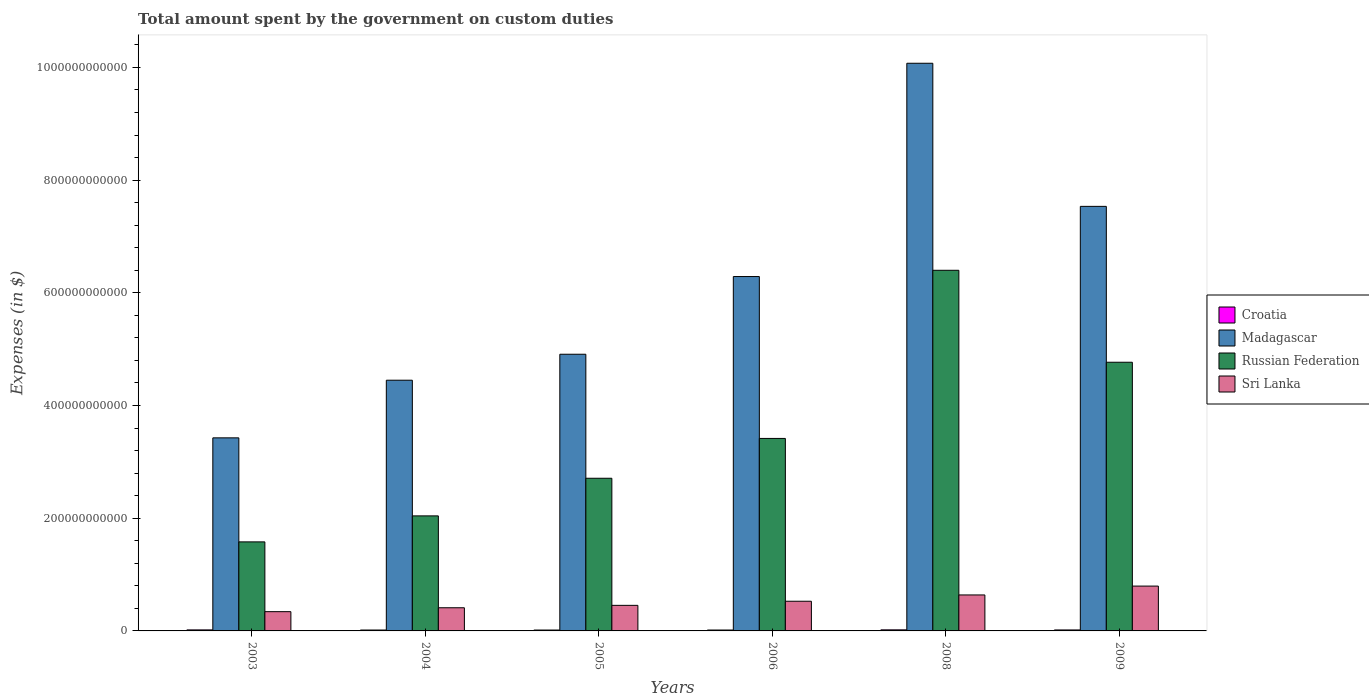How many groups of bars are there?
Ensure brevity in your answer.  6. Are the number of bars per tick equal to the number of legend labels?
Provide a succinct answer. Yes. In how many cases, is the number of bars for a given year not equal to the number of legend labels?
Your answer should be very brief. 0. What is the amount spent on custom duties by the government in Russian Federation in 2004?
Provide a succinct answer. 2.04e+11. Across all years, what is the maximum amount spent on custom duties by the government in Russian Federation?
Your response must be concise. 6.40e+11. Across all years, what is the minimum amount spent on custom duties by the government in Sri Lanka?
Make the answer very short. 3.42e+1. In which year was the amount spent on custom duties by the government in Russian Federation maximum?
Make the answer very short. 2008. In which year was the amount spent on custom duties by the government in Sri Lanka minimum?
Ensure brevity in your answer.  2003. What is the total amount spent on custom duties by the government in Croatia in the graph?
Your answer should be very brief. 1.02e+1. What is the difference between the amount spent on custom duties by the government in Sri Lanka in 2004 and that in 2006?
Your response must be concise. -1.16e+1. What is the difference between the amount spent on custom duties by the government in Sri Lanka in 2003 and the amount spent on custom duties by the government in Madagascar in 2005?
Ensure brevity in your answer.  -4.57e+11. What is the average amount spent on custom duties by the government in Croatia per year?
Provide a succinct answer. 1.70e+09. In the year 2008, what is the difference between the amount spent on custom duties by the government in Croatia and amount spent on custom duties by the government in Russian Federation?
Offer a very short reply. -6.38e+11. In how many years, is the amount spent on custom duties by the government in Sri Lanka greater than 120000000000 $?
Provide a succinct answer. 0. What is the ratio of the amount spent on custom duties by the government in Croatia in 2005 to that in 2006?
Keep it short and to the point. 0.98. Is the amount spent on custom duties by the government in Madagascar in 2004 less than that in 2008?
Provide a succinct answer. Yes. Is the difference between the amount spent on custom duties by the government in Croatia in 2003 and 2006 greater than the difference between the amount spent on custom duties by the government in Russian Federation in 2003 and 2006?
Offer a very short reply. Yes. What is the difference between the highest and the second highest amount spent on custom duties by the government in Russian Federation?
Your answer should be compact. 1.63e+11. What is the difference between the highest and the lowest amount spent on custom duties by the government in Russian Federation?
Offer a terse response. 4.82e+11. In how many years, is the amount spent on custom duties by the government in Madagascar greater than the average amount spent on custom duties by the government in Madagascar taken over all years?
Your answer should be compact. 3. What does the 4th bar from the left in 2004 represents?
Offer a terse response. Sri Lanka. What does the 1st bar from the right in 2003 represents?
Your answer should be compact. Sri Lanka. How many bars are there?
Provide a succinct answer. 24. How many years are there in the graph?
Your response must be concise. 6. What is the difference between two consecutive major ticks on the Y-axis?
Your answer should be compact. 2.00e+11. Are the values on the major ticks of Y-axis written in scientific E-notation?
Make the answer very short. No. How are the legend labels stacked?
Your response must be concise. Vertical. What is the title of the graph?
Your response must be concise. Total amount spent by the government on custom duties. Does "Hong Kong" appear as one of the legend labels in the graph?
Offer a terse response. No. What is the label or title of the X-axis?
Provide a short and direct response. Years. What is the label or title of the Y-axis?
Offer a very short reply. Expenses (in $). What is the Expenses (in $) in Croatia in 2003?
Give a very brief answer. 1.81e+09. What is the Expenses (in $) in Madagascar in 2003?
Provide a succinct answer. 3.43e+11. What is the Expenses (in $) of Russian Federation in 2003?
Give a very brief answer. 1.58e+11. What is the Expenses (in $) in Sri Lanka in 2003?
Provide a succinct answer. 3.42e+1. What is the Expenses (in $) in Croatia in 2004?
Offer a very short reply. 1.59e+09. What is the Expenses (in $) in Madagascar in 2004?
Offer a very short reply. 4.45e+11. What is the Expenses (in $) in Russian Federation in 2004?
Your response must be concise. 2.04e+11. What is the Expenses (in $) of Sri Lanka in 2004?
Make the answer very short. 4.11e+1. What is the Expenses (in $) in Croatia in 2005?
Provide a short and direct response. 1.56e+09. What is the Expenses (in $) in Madagascar in 2005?
Offer a terse response. 4.91e+11. What is the Expenses (in $) in Russian Federation in 2005?
Offer a very short reply. 2.71e+11. What is the Expenses (in $) of Sri Lanka in 2005?
Ensure brevity in your answer.  4.54e+1. What is the Expenses (in $) of Croatia in 2006?
Give a very brief answer. 1.59e+09. What is the Expenses (in $) of Madagascar in 2006?
Ensure brevity in your answer.  6.29e+11. What is the Expenses (in $) in Russian Federation in 2006?
Offer a terse response. 3.42e+11. What is the Expenses (in $) of Sri Lanka in 2006?
Your response must be concise. 5.27e+1. What is the Expenses (in $) in Croatia in 2008?
Offer a terse response. 1.90e+09. What is the Expenses (in $) in Madagascar in 2008?
Provide a succinct answer. 1.01e+12. What is the Expenses (in $) in Russian Federation in 2008?
Offer a terse response. 6.40e+11. What is the Expenses (in $) in Sri Lanka in 2008?
Provide a succinct answer. 6.38e+1. What is the Expenses (in $) in Croatia in 2009?
Offer a very short reply. 1.72e+09. What is the Expenses (in $) of Madagascar in 2009?
Make the answer very short. 7.53e+11. What is the Expenses (in $) in Russian Federation in 2009?
Offer a terse response. 4.77e+11. What is the Expenses (in $) of Sri Lanka in 2009?
Keep it short and to the point. 7.96e+1. Across all years, what is the maximum Expenses (in $) of Croatia?
Your answer should be very brief. 1.90e+09. Across all years, what is the maximum Expenses (in $) in Madagascar?
Provide a short and direct response. 1.01e+12. Across all years, what is the maximum Expenses (in $) in Russian Federation?
Give a very brief answer. 6.40e+11. Across all years, what is the maximum Expenses (in $) in Sri Lanka?
Offer a terse response. 7.96e+1. Across all years, what is the minimum Expenses (in $) in Croatia?
Provide a succinct answer. 1.56e+09. Across all years, what is the minimum Expenses (in $) of Madagascar?
Make the answer very short. 3.43e+11. Across all years, what is the minimum Expenses (in $) of Russian Federation?
Make the answer very short. 1.58e+11. Across all years, what is the minimum Expenses (in $) of Sri Lanka?
Your response must be concise. 3.42e+1. What is the total Expenses (in $) in Croatia in the graph?
Offer a terse response. 1.02e+1. What is the total Expenses (in $) in Madagascar in the graph?
Offer a very short reply. 3.67e+12. What is the total Expenses (in $) in Russian Federation in the graph?
Provide a succinct answer. 2.09e+12. What is the total Expenses (in $) of Sri Lanka in the graph?
Your response must be concise. 3.17e+11. What is the difference between the Expenses (in $) in Croatia in 2003 and that in 2004?
Your answer should be compact. 2.20e+08. What is the difference between the Expenses (in $) in Madagascar in 2003 and that in 2004?
Make the answer very short. -1.02e+11. What is the difference between the Expenses (in $) of Russian Federation in 2003 and that in 2004?
Give a very brief answer. -4.61e+1. What is the difference between the Expenses (in $) in Sri Lanka in 2003 and that in 2004?
Offer a terse response. -6.91e+09. What is the difference between the Expenses (in $) in Croatia in 2003 and that in 2005?
Give a very brief answer. 2.48e+08. What is the difference between the Expenses (in $) of Madagascar in 2003 and that in 2005?
Ensure brevity in your answer.  -1.48e+11. What is the difference between the Expenses (in $) of Russian Federation in 2003 and that in 2005?
Keep it short and to the point. -1.13e+11. What is the difference between the Expenses (in $) in Sri Lanka in 2003 and that in 2005?
Offer a very short reply. -1.12e+1. What is the difference between the Expenses (in $) of Croatia in 2003 and that in 2006?
Make the answer very short. 2.22e+08. What is the difference between the Expenses (in $) of Madagascar in 2003 and that in 2006?
Give a very brief answer. -2.86e+11. What is the difference between the Expenses (in $) in Russian Federation in 2003 and that in 2006?
Offer a terse response. -1.84e+11. What is the difference between the Expenses (in $) in Sri Lanka in 2003 and that in 2006?
Ensure brevity in your answer.  -1.85e+1. What is the difference between the Expenses (in $) in Croatia in 2003 and that in 2008?
Offer a terse response. -9.01e+07. What is the difference between the Expenses (in $) in Madagascar in 2003 and that in 2008?
Your response must be concise. -6.65e+11. What is the difference between the Expenses (in $) of Russian Federation in 2003 and that in 2008?
Provide a succinct answer. -4.82e+11. What is the difference between the Expenses (in $) of Sri Lanka in 2003 and that in 2008?
Provide a short and direct response. -2.97e+1. What is the difference between the Expenses (in $) in Croatia in 2003 and that in 2009?
Offer a terse response. 8.97e+07. What is the difference between the Expenses (in $) of Madagascar in 2003 and that in 2009?
Make the answer very short. -4.11e+11. What is the difference between the Expenses (in $) in Russian Federation in 2003 and that in 2009?
Give a very brief answer. -3.19e+11. What is the difference between the Expenses (in $) in Sri Lanka in 2003 and that in 2009?
Offer a very short reply. -4.54e+1. What is the difference between the Expenses (in $) of Croatia in 2004 and that in 2005?
Provide a succinct answer. 2.78e+07. What is the difference between the Expenses (in $) in Madagascar in 2004 and that in 2005?
Offer a terse response. -4.61e+1. What is the difference between the Expenses (in $) of Russian Federation in 2004 and that in 2005?
Ensure brevity in your answer.  -6.68e+1. What is the difference between the Expenses (in $) of Sri Lanka in 2004 and that in 2005?
Your response must be concise. -4.29e+09. What is the difference between the Expenses (in $) in Croatia in 2004 and that in 2006?
Keep it short and to the point. 1.70e+06. What is the difference between the Expenses (in $) of Madagascar in 2004 and that in 2006?
Ensure brevity in your answer.  -1.84e+11. What is the difference between the Expenses (in $) of Russian Federation in 2004 and that in 2006?
Provide a succinct answer. -1.37e+11. What is the difference between the Expenses (in $) of Sri Lanka in 2004 and that in 2006?
Give a very brief answer. -1.16e+1. What is the difference between the Expenses (in $) of Croatia in 2004 and that in 2008?
Offer a very short reply. -3.10e+08. What is the difference between the Expenses (in $) in Madagascar in 2004 and that in 2008?
Make the answer very short. -5.62e+11. What is the difference between the Expenses (in $) of Russian Federation in 2004 and that in 2008?
Keep it short and to the point. -4.36e+11. What is the difference between the Expenses (in $) of Sri Lanka in 2004 and that in 2008?
Offer a terse response. -2.27e+1. What is the difference between the Expenses (in $) in Croatia in 2004 and that in 2009?
Offer a terse response. -1.30e+08. What is the difference between the Expenses (in $) in Madagascar in 2004 and that in 2009?
Ensure brevity in your answer.  -3.09e+11. What is the difference between the Expenses (in $) in Russian Federation in 2004 and that in 2009?
Ensure brevity in your answer.  -2.73e+11. What is the difference between the Expenses (in $) in Sri Lanka in 2004 and that in 2009?
Give a very brief answer. -3.85e+1. What is the difference between the Expenses (in $) of Croatia in 2005 and that in 2006?
Offer a terse response. -2.61e+07. What is the difference between the Expenses (in $) in Madagascar in 2005 and that in 2006?
Provide a succinct answer. -1.38e+11. What is the difference between the Expenses (in $) of Russian Federation in 2005 and that in 2006?
Your response must be concise. -7.07e+1. What is the difference between the Expenses (in $) of Sri Lanka in 2005 and that in 2006?
Offer a terse response. -7.27e+09. What is the difference between the Expenses (in $) of Croatia in 2005 and that in 2008?
Provide a succinct answer. -3.38e+08. What is the difference between the Expenses (in $) of Madagascar in 2005 and that in 2008?
Make the answer very short. -5.16e+11. What is the difference between the Expenses (in $) in Russian Federation in 2005 and that in 2008?
Provide a short and direct response. -3.69e+11. What is the difference between the Expenses (in $) in Sri Lanka in 2005 and that in 2008?
Your response must be concise. -1.85e+1. What is the difference between the Expenses (in $) of Croatia in 2005 and that in 2009?
Provide a short and direct response. -1.58e+08. What is the difference between the Expenses (in $) of Madagascar in 2005 and that in 2009?
Your response must be concise. -2.62e+11. What is the difference between the Expenses (in $) of Russian Federation in 2005 and that in 2009?
Your response must be concise. -2.06e+11. What is the difference between the Expenses (in $) in Sri Lanka in 2005 and that in 2009?
Offer a terse response. -3.42e+1. What is the difference between the Expenses (in $) in Croatia in 2006 and that in 2008?
Offer a very short reply. -3.12e+08. What is the difference between the Expenses (in $) of Madagascar in 2006 and that in 2008?
Make the answer very short. -3.78e+11. What is the difference between the Expenses (in $) of Russian Federation in 2006 and that in 2008?
Give a very brief answer. -2.98e+11. What is the difference between the Expenses (in $) of Sri Lanka in 2006 and that in 2008?
Your answer should be compact. -1.12e+1. What is the difference between the Expenses (in $) of Croatia in 2006 and that in 2009?
Make the answer very short. -1.32e+08. What is the difference between the Expenses (in $) of Madagascar in 2006 and that in 2009?
Make the answer very short. -1.25e+11. What is the difference between the Expenses (in $) in Russian Federation in 2006 and that in 2009?
Provide a succinct answer. -1.35e+11. What is the difference between the Expenses (in $) in Sri Lanka in 2006 and that in 2009?
Offer a very short reply. -2.69e+1. What is the difference between the Expenses (in $) in Croatia in 2008 and that in 2009?
Your answer should be compact. 1.80e+08. What is the difference between the Expenses (in $) of Madagascar in 2008 and that in 2009?
Provide a short and direct response. 2.54e+11. What is the difference between the Expenses (in $) of Russian Federation in 2008 and that in 2009?
Keep it short and to the point. 1.63e+11. What is the difference between the Expenses (in $) in Sri Lanka in 2008 and that in 2009?
Your answer should be compact. -1.57e+1. What is the difference between the Expenses (in $) in Croatia in 2003 and the Expenses (in $) in Madagascar in 2004?
Ensure brevity in your answer.  -4.43e+11. What is the difference between the Expenses (in $) in Croatia in 2003 and the Expenses (in $) in Russian Federation in 2004?
Give a very brief answer. -2.02e+11. What is the difference between the Expenses (in $) of Croatia in 2003 and the Expenses (in $) of Sri Lanka in 2004?
Provide a short and direct response. -3.93e+1. What is the difference between the Expenses (in $) of Madagascar in 2003 and the Expenses (in $) of Russian Federation in 2004?
Your answer should be very brief. 1.38e+11. What is the difference between the Expenses (in $) in Madagascar in 2003 and the Expenses (in $) in Sri Lanka in 2004?
Keep it short and to the point. 3.02e+11. What is the difference between the Expenses (in $) of Russian Federation in 2003 and the Expenses (in $) of Sri Lanka in 2004?
Give a very brief answer. 1.17e+11. What is the difference between the Expenses (in $) of Croatia in 2003 and the Expenses (in $) of Madagascar in 2005?
Provide a succinct answer. -4.89e+11. What is the difference between the Expenses (in $) of Croatia in 2003 and the Expenses (in $) of Russian Federation in 2005?
Ensure brevity in your answer.  -2.69e+11. What is the difference between the Expenses (in $) of Croatia in 2003 and the Expenses (in $) of Sri Lanka in 2005?
Keep it short and to the point. -4.36e+1. What is the difference between the Expenses (in $) of Madagascar in 2003 and the Expenses (in $) of Russian Federation in 2005?
Keep it short and to the point. 7.17e+1. What is the difference between the Expenses (in $) in Madagascar in 2003 and the Expenses (in $) in Sri Lanka in 2005?
Make the answer very short. 2.97e+11. What is the difference between the Expenses (in $) of Russian Federation in 2003 and the Expenses (in $) of Sri Lanka in 2005?
Your answer should be compact. 1.13e+11. What is the difference between the Expenses (in $) of Croatia in 2003 and the Expenses (in $) of Madagascar in 2006?
Your response must be concise. -6.27e+11. What is the difference between the Expenses (in $) of Croatia in 2003 and the Expenses (in $) of Russian Federation in 2006?
Give a very brief answer. -3.40e+11. What is the difference between the Expenses (in $) of Croatia in 2003 and the Expenses (in $) of Sri Lanka in 2006?
Keep it short and to the point. -5.09e+1. What is the difference between the Expenses (in $) of Madagascar in 2003 and the Expenses (in $) of Russian Federation in 2006?
Provide a short and direct response. 1.03e+09. What is the difference between the Expenses (in $) in Madagascar in 2003 and the Expenses (in $) in Sri Lanka in 2006?
Keep it short and to the point. 2.90e+11. What is the difference between the Expenses (in $) in Russian Federation in 2003 and the Expenses (in $) in Sri Lanka in 2006?
Your answer should be very brief. 1.05e+11. What is the difference between the Expenses (in $) of Croatia in 2003 and the Expenses (in $) of Madagascar in 2008?
Your response must be concise. -1.01e+12. What is the difference between the Expenses (in $) of Croatia in 2003 and the Expenses (in $) of Russian Federation in 2008?
Offer a terse response. -6.38e+11. What is the difference between the Expenses (in $) in Croatia in 2003 and the Expenses (in $) in Sri Lanka in 2008?
Your answer should be very brief. -6.20e+1. What is the difference between the Expenses (in $) in Madagascar in 2003 and the Expenses (in $) in Russian Federation in 2008?
Make the answer very short. -2.97e+11. What is the difference between the Expenses (in $) in Madagascar in 2003 and the Expenses (in $) in Sri Lanka in 2008?
Your answer should be very brief. 2.79e+11. What is the difference between the Expenses (in $) of Russian Federation in 2003 and the Expenses (in $) of Sri Lanka in 2008?
Your response must be concise. 9.42e+1. What is the difference between the Expenses (in $) in Croatia in 2003 and the Expenses (in $) in Madagascar in 2009?
Ensure brevity in your answer.  -7.52e+11. What is the difference between the Expenses (in $) in Croatia in 2003 and the Expenses (in $) in Russian Federation in 2009?
Your response must be concise. -4.75e+11. What is the difference between the Expenses (in $) in Croatia in 2003 and the Expenses (in $) in Sri Lanka in 2009?
Ensure brevity in your answer.  -7.77e+1. What is the difference between the Expenses (in $) in Madagascar in 2003 and the Expenses (in $) in Russian Federation in 2009?
Your answer should be very brief. -1.34e+11. What is the difference between the Expenses (in $) in Madagascar in 2003 and the Expenses (in $) in Sri Lanka in 2009?
Provide a short and direct response. 2.63e+11. What is the difference between the Expenses (in $) in Russian Federation in 2003 and the Expenses (in $) in Sri Lanka in 2009?
Give a very brief answer. 7.84e+1. What is the difference between the Expenses (in $) in Croatia in 2004 and the Expenses (in $) in Madagascar in 2005?
Ensure brevity in your answer.  -4.89e+11. What is the difference between the Expenses (in $) of Croatia in 2004 and the Expenses (in $) of Russian Federation in 2005?
Provide a succinct answer. -2.69e+11. What is the difference between the Expenses (in $) in Croatia in 2004 and the Expenses (in $) in Sri Lanka in 2005?
Your answer should be very brief. -4.38e+1. What is the difference between the Expenses (in $) in Madagascar in 2004 and the Expenses (in $) in Russian Federation in 2005?
Make the answer very short. 1.74e+11. What is the difference between the Expenses (in $) in Madagascar in 2004 and the Expenses (in $) in Sri Lanka in 2005?
Make the answer very short. 4.00e+11. What is the difference between the Expenses (in $) in Russian Federation in 2004 and the Expenses (in $) in Sri Lanka in 2005?
Ensure brevity in your answer.  1.59e+11. What is the difference between the Expenses (in $) of Croatia in 2004 and the Expenses (in $) of Madagascar in 2006?
Give a very brief answer. -6.27e+11. What is the difference between the Expenses (in $) of Croatia in 2004 and the Expenses (in $) of Russian Federation in 2006?
Your response must be concise. -3.40e+11. What is the difference between the Expenses (in $) in Croatia in 2004 and the Expenses (in $) in Sri Lanka in 2006?
Your answer should be compact. -5.11e+1. What is the difference between the Expenses (in $) of Madagascar in 2004 and the Expenses (in $) of Russian Federation in 2006?
Offer a terse response. 1.03e+11. What is the difference between the Expenses (in $) of Madagascar in 2004 and the Expenses (in $) of Sri Lanka in 2006?
Offer a very short reply. 3.92e+11. What is the difference between the Expenses (in $) in Russian Federation in 2004 and the Expenses (in $) in Sri Lanka in 2006?
Keep it short and to the point. 1.51e+11. What is the difference between the Expenses (in $) in Croatia in 2004 and the Expenses (in $) in Madagascar in 2008?
Your answer should be compact. -1.01e+12. What is the difference between the Expenses (in $) of Croatia in 2004 and the Expenses (in $) of Russian Federation in 2008?
Keep it short and to the point. -6.38e+11. What is the difference between the Expenses (in $) in Croatia in 2004 and the Expenses (in $) in Sri Lanka in 2008?
Your answer should be compact. -6.23e+1. What is the difference between the Expenses (in $) in Madagascar in 2004 and the Expenses (in $) in Russian Federation in 2008?
Ensure brevity in your answer.  -1.95e+11. What is the difference between the Expenses (in $) of Madagascar in 2004 and the Expenses (in $) of Sri Lanka in 2008?
Your response must be concise. 3.81e+11. What is the difference between the Expenses (in $) of Russian Federation in 2004 and the Expenses (in $) of Sri Lanka in 2008?
Give a very brief answer. 1.40e+11. What is the difference between the Expenses (in $) in Croatia in 2004 and the Expenses (in $) in Madagascar in 2009?
Your response must be concise. -7.52e+11. What is the difference between the Expenses (in $) of Croatia in 2004 and the Expenses (in $) of Russian Federation in 2009?
Your answer should be compact. -4.75e+11. What is the difference between the Expenses (in $) in Croatia in 2004 and the Expenses (in $) in Sri Lanka in 2009?
Ensure brevity in your answer.  -7.80e+1. What is the difference between the Expenses (in $) of Madagascar in 2004 and the Expenses (in $) of Russian Federation in 2009?
Ensure brevity in your answer.  -3.19e+1. What is the difference between the Expenses (in $) of Madagascar in 2004 and the Expenses (in $) of Sri Lanka in 2009?
Keep it short and to the point. 3.65e+11. What is the difference between the Expenses (in $) of Russian Federation in 2004 and the Expenses (in $) of Sri Lanka in 2009?
Provide a succinct answer. 1.25e+11. What is the difference between the Expenses (in $) in Croatia in 2005 and the Expenses (in $) in Madagascar in 2006?
Your response must be concise. -6.27e+11. What is the difference between the Expenses (in $) in Croatia in 2005 and the Expenses (in $) in Russian Federation in 2006?
Give a very brief answer. -3.40e+11. What is the difference between the Expenses (in $) in Croatia in 2005 and the Expenses (in $) in Sri Lanka in 2006?
Offer a terse response. -5.11e+1. What is the difference between the Expenses (in $) of Madagascar in 2005 and the Expenses (in $) of Russian Federation in 2006?
Give a very brief answer. 1.49e+11. What is the difference between the Expenses (in $) in Madagascar in 2005 and the Expenses (in $) in Sri Lanka in 2006?
Ensure brevity in your answer.  4.38e+11. What is the difference between the Expenses (in $) of Russian Federation in 2005 and the Expenses (in $) of Sri Lanka in 2006?
Your answer should be compact. 2.18e+11. What is the difference between the Expenses (in $) in Croatia in 2005 and the Expenses (in $) in Madagascar in 2008?
Give a very brief answer. -1.01e+12. What is the difference between the Expenses (in $) of Croatia in 2005 and the Expenses (in $) of Russian Federation in 2008?
Offer a terse response. -6.38e+11. What is the difference between the Expenses (in $) of Croatia in 2005 and the Expenses (in $) of Sri Lanka in 2008?
Provide a short and direct response. -6.23e+1. What is the difference between the Expenses (in $) of Madagascar in 2005 and the Expenses (in $) of Russian Federation in 2008?
Give a very brief answer. -1.49e+11. What is the difference between the Expenses (in $) of Madagascar in 2005 and the Expenses (in $) of Sri Lanka in 2008?
Your answer should be compact. 4.27e+11. What is the difference between the Expenses (in $) in Russian Federation in 2005 and the Expenses (in $) in Sri Lanka in 2008?
Keep it short and to the point. 2.07e+11. What is the difference between the Expenses (in $) of Croatia in 2005 and the Expenses (in $) of Madagascar in 2009?
Make the answer very short. -7.52e+11. What is the difference between the Expenses (in $) in Croatia in 2005 and the Expenses (in $) in Russian Federation in 2009?
Offer a very short reply. -4.75e+11. What is the difference between the Expenses (in $) in Croatia in 2005 and the Expenses (in $) in Sri Lanka in 2009?
Your answer should be compact. -7.80e+1. What is the difference between the Expenses (in $) in Madagascar in 2005 and the Expenses (in $) in Russian Federation in 2009?
Make the answer very short. 1.42e+1. What is the difference between the Expenses (in $) in Madagascar in 2005 and the Expenses (in $) in Sri Lanka in 2009?
Ensure brevity in your answer.  4.11e+11. What is the difference between the Expenses (in $) of Russian Federation in 2005 and the Expenses (in $) of Sri Lanka in 2009?
Your answer should be very brief. 1.91e+11. What is the difference between the Expenses (in $) in Croatia in 2006 and the Expenses (in $) in Madagascar in 2008?
Provide a short and direct response. -1.01e+12. What is the difference between the Expenses (in $) of Croatia in 2006 and the Expenses (in $) of Russian Federation in 2008?
Keep it short and to the point. -6.38e+11. What is the difference between the Expenses (in $) in Croatia in 2006 and the Expenses (in $) in Sri Lanka in 2008?
Your response must be concise. -6.23e+1. What is the difference between the Expenses (in $) in Madagascar in 2006 and the Expenses (in $) in Russian Federation in 2008?
Keep it short and to the point. -1.11e+1. What is the difference between the Expenses (in $) in Madagascar in 2006 and the Expenses (in $) in Sri Lanka in 2008?
Provide a short and direct response. 5.65e+11. What is the difference between the Expenses (in $) in Russian Federation in 2006 and the Expenses (in $) in Sri Lanka in 2008?
Provide a succinct answer. 2.78e+11. What is the difference between the Expenses (in $) in Croatia in 2006 and the Expenses (in $) in Madagascar in 2009?
Offer a terse response. -7.52e+11. What is the difference between the Expenses (in $) of Croatia in 2006 and the Expenses (in $) of Russian Federation in 2009?
Make the answer very short. -4.75e+11. What is the difference between the Expenses (in $) in Croatia in 2006 and the Expenses (in $) in Sri Lanka in 2009?
Provide a succinct answer. -7.80e+1. What is the difference between the Expenses (in $) of Madagascar in 2006 and the Expenses (in $) of Russian Federation in 2009?
Offer a terse response. 1.52e+11. What is the difference between the Expenses (in $) of Madagascar in 2006 and the Expenses (in $) of Sri Lanka in 2009?
Offer a terse response. 5.49e+11. What is the difference between the Expenses (in $) in Russian Federation in 2006 and the Expenses (in $) in Sri Lanka in 2009?
Offer a very short reply. 2.62e+11. What is the difference between the Expenses (in $) in Croatia in 2008 and the Expenses (in $) in Madagascar in 2009?
Your response must be concise. -7.52e+11. What is the difference between the Expenses (in $) in Croatia in 2008 and the Expenses (in $) in Russian Federation in 2009?
Provide a short and direct response. -4.75e+11. What is the difference between the Expenses (in $) in Croatia in 2008 and the Expenses (in $) in Sri Lanka in 2009?
Offer a terse response. -7.77e+1. What is the difference between the Expenses (in $) of Madagascar in 2008 and the Expenses (in $) of Russian Federation in 2009?
Provide a short and direct response. 5.31e+11. What is the difference between the Expenses (in $) in Madagascar in 2008 and the Expenses (in $) in Sri Lanka in 2009?
Provide a short and direct response. 9.28e+11. What is the difference between the Expenses (in $) in Russian Federation in 2008 and the Expenses (in $) in Sri Lanka in 2009?
Keep it short and to the point. 5.60e+11. What is the average Expenses (in $) of Croatia per year?
Give a very brief answer. 1.70e+09. What is the average Expenses (in $) in Madagascar per year?
Your answer should be very brief. 6.11e+11. What is the average Expenses (in $) of Russian Federation per year?
Keep it short and to the point. 3.49e+11. What is the average Expenses (in $) in Sri Lanka per year?
Make the answer very short. 5.28e+1. In the year 2003, what is the difference between the Expenses (in $) in Croatia and Expenses (in $) in Madagascar?
Your response must be concise. -3.41e+11. In the year 2003, what is the difference between the Expenses (in $) of Croatia and Expenses (in $) of Russian Federation?
Offer a terse response. -1.56e+11. In the year 2003, what is the difference between the Expenses (in $) in Croatia and Expenses (in $) in Sri Lanka?
Your response must be concise. -3.24e+1. In the year 2003, what is the difference between the Expenses (in $) in Madagascar and Expenses (in $) in Russian Federation?
Ensure brevity in your answer.  1.85e+11. In the year 2003, what is the difference between the Expenses (in $) of Madagascar and Expenses (in $) of Sri Lanka?
Offer a terse response. 3.08e+11. In the year 2003, what is the difference between the Expenses (in $) of Russian Federation and Expenses (in $) of Sri Lanka?
Offer a terse response. 1.24e+11. In the year 2004, what is the difference between the Expenses (in $) in Croatia and Expenses (in $) in Madagascar?
Keep it short and to the point. -4.43e+11. In the year 2004, what is the difference between the Expenses (in $) in Croatia and Expenses (in $) in Russian Federation?
Make the answer very short. -2.03e+11. In the year 2004, what is the difference between the Expenses (in $) of Croatia and Expenses (in $) of Sri Lanka?
Your response must be concise. -3.95e+1. In the year 2004, what is the difference between the Expenses (in $) of Madagascar and Expenses (in $) of Russian Federation?
Your answer should be compact. 2.41e+11. In the year 2004, what is the difference between the Expenses (in $) of Madagascar and Expenses (in $) of Sri Lanka?
Your answer should be very brief. 4.04e+11. In the year 2004, what is the difference between the Expenses (in $) in Russian Federation and Expenses (in $) in Sri Lanka?
Make the answer very short. 1.63e+11. In the year 2005, what is the difference between the Expenses (in $) of Croatia and Expenses (in $) of Madagascar?
Offer a very short reply. -4.89e+11. In the year 2005, what is the difference between the Expenses (in $) in Croatia and Expenses (in $) in Russian Federation?
Your response must be concise. -2.69e+11. In the year 2005, what is the difference between the Expenses (in $) in Croatia and Expenses (in $) in Sri Lanka?
Give a very brief answer. -4.38e+1. In the year 2005, what is the difference between the Expenses (in $) of Madagascar and Expenses (in $) of Russian Federation?
Your response must be concise. 2.20e+11. In the year 2005, what is the difference between the Expenses (in $) of Madagascar and Expenses (in $) of Sri Lanka?
Your answer should be compact. 4.46e+11. In the year 2005, what is the difference between the Expenses (in $) in Russian Federation and Expenses (in $) in Sri Lanka?
Offer a terse response. 2.26e+11. In the year 2006, what is the difference between the Expenses (in $) of Croatia and Expenses (in $) of Madagascar?
Ensure brevity in your answer.  -6.27e+11. In the year 2006, what is the difference between the Expenses (in $) of Croatia and Expenses (in $) of Russian Federation?
Make the answer very short. -3.40e+11. In the year 2006, what is the difference between the Expenses (in $) in Croatia and Expenses (in $) in Sri Lanka?
Your answer should be very brief. -5.11e+1. In the year 2006, what is the difference between the Expenses (in $) in Madagascar and Expenses (in $) in Russian Federation?
Your response must be concise. 2.87e+11. In the year 2006, what is the difference between the Expenses (in $) of Madagascar and Expenses (in $) of Sri Lanka?
Give a very brief answer. 5.76e+11. In the year 2006, what is the difference between the Expenses (in $) of Russian Federation and Expenses (in $) of Sri Lanka?
Offer a terse response. 2.89e+11. In the year 2008, what is the difference between the Expenses (in $) in Croatia and Expenses (in $) in Madagascar?
Keep it short and to the point. -1.01e+12. In the year 2008, what is the difference between the Expenses (in $) in Croatia and Expenses (in $) in Russian Federation?
Give a very brief answer. -6.38e+11. In the year 2008, what is the difference between the Expenses (in $) of Croatia and Expenses (in $) of Sri Lanka?
Provide a short and direct response. -6.19e+1. In the year 2008, what is the difference between the Expenses (in $) in Madagascar and Expenses (in $) in Russian Federation?
Provide a succinct answer. 3.67e+11. In the year 2008, what is the difference between the Expenses (in $) of Madagascar and Expenses (in $) of Sri Lanka?
Your answer should be very brief. 9.44e+11. In the year 2008, what is the difference between the Expenses (in $) in Russian Federation and Expenses (in $) in Sri Lanka?
Provide a succinct answer. 5.76e+11. In the year 2009, what is the difference between the Expenses (in $) in Croatia and Expenses (in $) in Madagascar?
Provide a succinct answer. -7.52e+11. In the year 2009, what is the difference between the Expenses (in $) in Croatia and Expenses (in $) in Russian Federation?
Make the answer very short. -4.75e+11. In the year 2009, what is the difference between the Expenses (in $) in Croatia and Expenses (in $) in Sri Lanka?
Your response must be concise. -7.78e+1. In the year 2009, what is the difference between the Expenses (in $) of Madagascar and Expenses (in $) of Russian Federation?
Your response must be concise. 2.77e+11. In the year 2009, what is the difference between the Expenses (in $) of Madagascar and Expenses (in $) of Sri Lanka?
Offer a terse response. 6.74e+11. In the year 2009, what is the difference between the Expenses (in $) of Russian Federation and Expenses (in $) of Sri Lanka?
Your response must be concise. 3.97e+11. What is the ratio of the Expenses (in $) in Croatia in 2003 to that in 2004?
Offer a very short reply. 1.14. What is the ratio of the Expenses (in $) of Madagascar in 2003 to that in 2004?
Keep it short and to the point. 0.77. What is the ratio of the Expenses (in $) in Russian Federation in 2003 to that in 2004?
Your answer should be very brief. 0.77. What is the ratio of the Expenses (in $) of Sri Lanka in 2003 to that in 2004?
Offer a terse response. 0.83. What is the ratio of the Expenses (in $) in Croatia in 2003 to that in 2005?
Offer a terse response. 1.16. What is the ratio of the Expenses (in $) in Madagascar in 2003 to that in 2005?
Provide a short and direct response. 0.7. What is the ratio of the Expenses (in $) in Russian Federation in 2003 to that in 2005?
Provide a succinct answer. 0.58. What is the ratio of the Expenses (in $) in Sri Lanka in 2003 to that in 2005?
Your response must be concise. 0.75. What is the ratio of the Expenses (in $) in Croatia in 2003 to that in 2006?
Make the answer very short. 1.14. What is the ratio of the Expenses (in $) of Madagascar in 2003 to that in 2006?
Offer a very short reply. 0.54. What is the ratio of the Expenses (in $) in Russian Federation in 2003 to that in 2006?
Your answer should be very brief. 0.46. What is the ratio of the Expenses (in $) of Sri Lanka in 2003 to that in 2006?
Your answer should be compact. 0.65. What is the ratio of the Expenses (in $) of Croatia in 2003 to that in 2008?
Ensure brevity in your answer.  0.95. What is the ratio of the Expenses (in $) in Madagascar in 2003 to that in 2008?
Offer a terse response. 0.34. What is the ratio of the Expenses (in $) of Russian Federation in 2003 to that in 2008?
Give a very brief answer. 0.25. What is the ratio of the Expenses (in $) of Sri Lanka in 2003 to that in 2008?
Your answer should be very brief. 0.54. What is the ratio of the Expenses (in $) of Croatia in 2003 to that in 2009?
Make the answer very short. 1.05. What is the ratio of the Expenses (in $) in Madagascar in 2003 to that in 2009?
Ensure brevity in your answer.  0.45. What is the ratio of the Expenses (in $) of Russian Federation in 2003 to that in 2009?
Make the answer very short. 0.33. What is the ratio of the Expenses (in $) of Sri Lanka in 2003 to that in 2009?
Provide a short and direct response. 0.43. What is the ratio of the Expenses (in $) of Croatia in 2004 to that in 2005?
Provide a short and direct response. 1.02. What is the ratio of the Expenses (in $) in Madagascar in 2004 to that in 2005?
Offer a very short reply. 0.91. What is the ratio of the Expenses (in $) in Russian Federation in 2004 to that in 2005?
Your answer should be compact. 0.75. What is the ratio of the Expenses (in $) of Sri Lanka in 2004 to that in 2005?
Provide a succinct answer. 0.91. What is the ratio of the Expenses (in $) in Madagascar in 2004 to that in 2006?
Provide a succinct answer. 0.71. What is the ratio of the Expenses (in $) in Russian Federation in 2004 to that in 2006?
Offer a terse response. 0.6. What is the ratio of the Expenses (in $) in Sri Lanka in 2004 to that in 2006?
Make the answer very short. 0.78. What is the ratio of the Expenses (in $) in Croatia in 2004 to that in 2008?
Your answer should be compact. 0.84. What is the ratio of the Expenses (in $) in Madagascar in 2004 to that in 2008?
Your answer should be compact. 0.44. What is the ratio of the Expenses (in $) of Russian Federation in 2004 to that in 2008?
Your answer should be compact. 0.32. What is the ratio of the Expenses (in $) of Sri Lanka in 2004 to that in 2008?
Provide a short and direct response. 0.64. What is the ratio of the Expenses (in $) in Croatia in 2004 to that in 2009?
Offer a terse response. 0.92. What is the ratio of the Expenses (in $) of Madagascar in 2004 to that in 2009?
Provide a succinct answer. 0.59. What is the ratio of the Expenses (in $) of Russian Federation in 2004 to that in 2009?
Make the answer very short. 0.43. What is the ratio of the Expenses (in $) of Sri Lanka in 2004 to that in 2009?
Your response must be concise. 0.52. What is the ratio of the Expenses (in $) in Croatia in 2005 to that in 2006?
Your answer should be very brief. 0.98. What is the ratio of the Expenses (in $) of Madagascar in 2005 to that in 2006?
Your answer should be compact. 0.78. What is the ratio of the Expenses (in $) in Russian Federation in 2005 to that in 2006?
Offer a very short reply. 0.79. What is the ratio of the Expenses (in $) in Sri Lanka in 2005 to that in 2006?
Your response must be concise. 0.86. What is the ratio of the Expenses (in $) of Croatia in 2005 to that in 2008?
Provide a succinct answer. 0.82. What is the ratio of the Expenses (in $) in Madagascar in 2005 to that in 2008?
Offer a terse response. 0.49. What is the ratio of the Expenses (in $) of Russian Federation in 2005 to that in 2008?
Your answer should be very brief. 0.42. What is the ratio of the Expenses (in $) in Sri Lanka in 2005 to that in 2008?
Provide a succinct answer. 0.71. What is the ratio of the Expenses (in $) of Croatia in 2005 to that in 2009?
Your response must be concise. 0.91. What is the ratio of the Expenses (in $) of Madagascar in 2005 to that in 2009?
Your answer should be very brief. 0.65. What is the ratio of the Expenses (in $) in Russian Federation in 2005 to that in 2009?
Your answer should be very brief. 0.57. What is the ratio of the Expenses (in $) in Sri Lanka in 2005 to that in 2009?
Your response must be concise. 0.57. What is the ratio of the Expenses (in $) of Croatia in 2006 to that in 2008?
Offer a terse response. 0.84. What is the ratio of the Expenses (in $) in Madagascar in 2006 to that in 2008?
Provide a short and direct response. 0.62. What is the ratio of the Expenses (in $) in Russian Federation in 2006 to that in 2008?
Your answer should be compact. 0.53. What is the ratio of the Expenses (in $) of Sri Lanka in 2006 to that in 2008?
Provide a short and direct response. 0.82. What is the ratio of the Expenses (in $) of Croatia in 2006 to that in 2009?
Your response must be concise. 0.92. What is the ratio of the Expenses (in $) in Madagascar in 2006 to that in 2009?
Provide a short and direct response. 0.83. What is the ratio of the Expenses (in $) in Russian Federation in 2006 to that in 2009?
Keep it short and to the point. 0.72. What is the ratio of the Expenses (in $) of Sri Lanka in 2006 to that in 2009?
Provide a succinct answer. 0.66. What is the ratio of the Expenses (in $) in Croatia in 2008 to that in 2009?
Your answer should be very brief. 1.1. What is the ratio of the Expenses (in $) in Madagascar in 2008 to that in 2009?
Offer a terse response. 1.34. What is the ratio of the Expenses (in $) of Russian Federation in 2008 to that in 2009?
Provide a succinct answer. 1.34. What is the ratio of the Expenses (in $) in Sri Lanka in 2008 to that in 2009?
Your answer should be very brief. 0.8. What is the difference between the highest and the second highest Expenses (in $) of Croatia?
Ensure brevity in your answer.  9.01e+07. What is the difference between the highest and the second highest Expenses (in $) in Madagascar?
Provide a succinct answer. 2.54e+11. What is the difference between the highest and the second highest Expenses (in $) in Russian Federation?
Your answer should be very brief. 1.63e+11. What is the difference between the highest and the second highest Expenses (in $) of Sri Lanka?
Provide a short and direct response. 1.57e+1. What is the difference between the highest and the lowest Expenses (in $) of Croatia?
Your answer should be compact. 3.38e+08. What is the difference between the highest and the lowest Expenses (in $) of Madagascar?
Provide a short and direct response. 6.65e+11. What is the difference between the highest and the lowest Expenses (in $) of Russian Federation?
Keep it short and to the point. 4.82e+11. What is the difference between the highest and the lowest Expenses (in $) in Sri Lanka?
Offer a very short reply. 4.54e+1. 